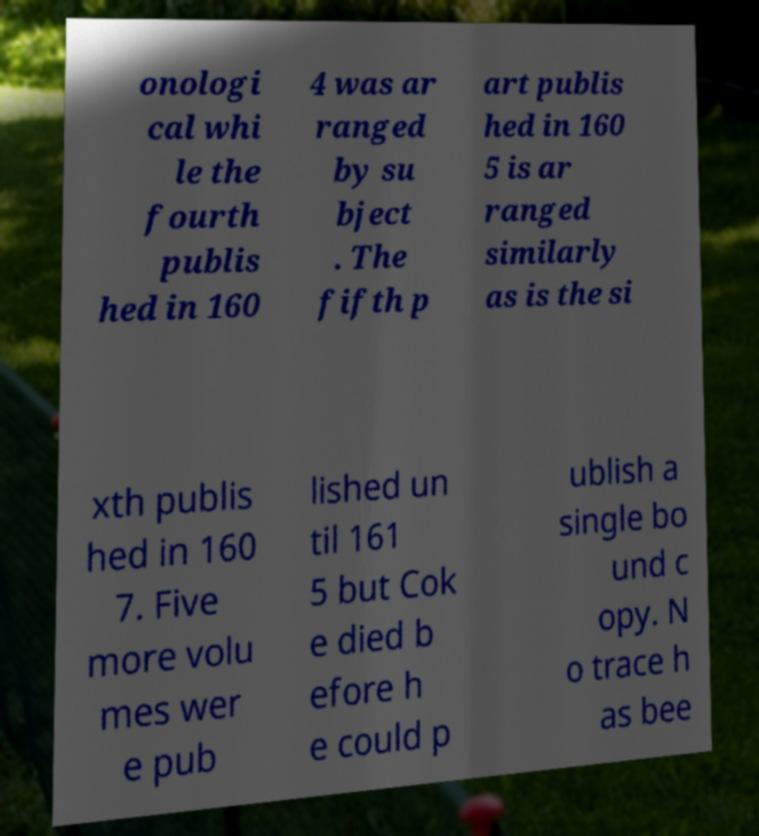Can you read and provide the text displayed in the image?This photo seems to have some interesting text. Can you extract and type it out for me? onologi cal whi le the fourth publis hed in 160 4 was ar ranged by su bject . The fifth p art publis hed in 160 5 is ar ranged similarly as is the si xth publis hed in 160 7. Five more volu mes wer e pub lished un til 161 5 but Cok e died b efore h e could p ublish a single bo und c opy. N o trace h as bee 